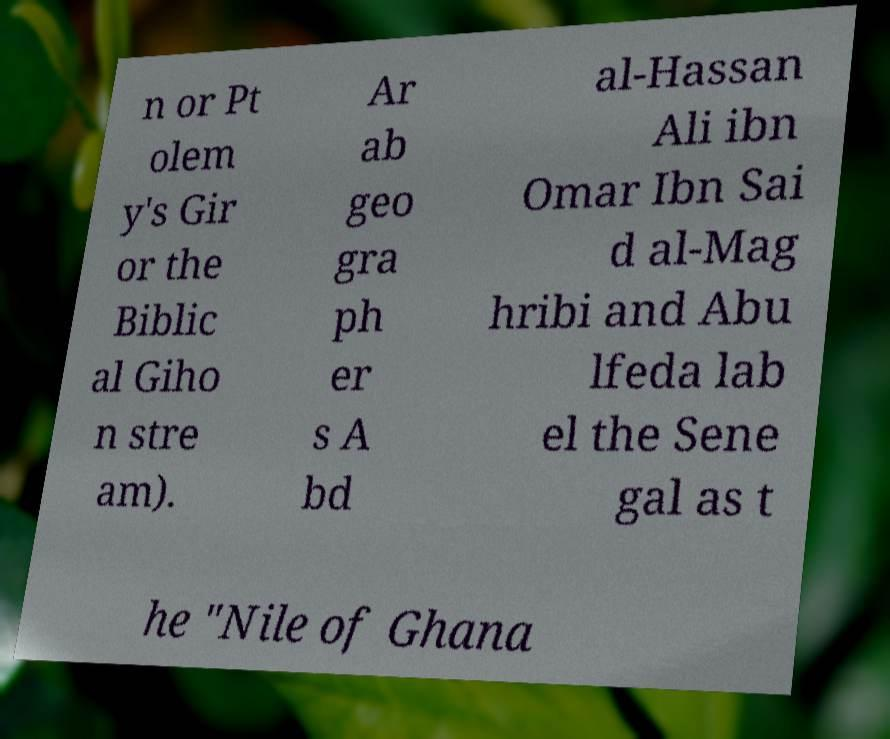Can you read and provide the text displayed in the image?This photo seems to have some interesting text. Can you extract and type it out for me? n or Pt olem y's Gir or the Biblic al Giho n stre am). Ar ab geo gra ph er s A bd al-Hassan Ali ibn Omar Ibn Sai d al-Mag hribi and Abu lfeda lab el the Sene gal as t he "Nile of Ghana 